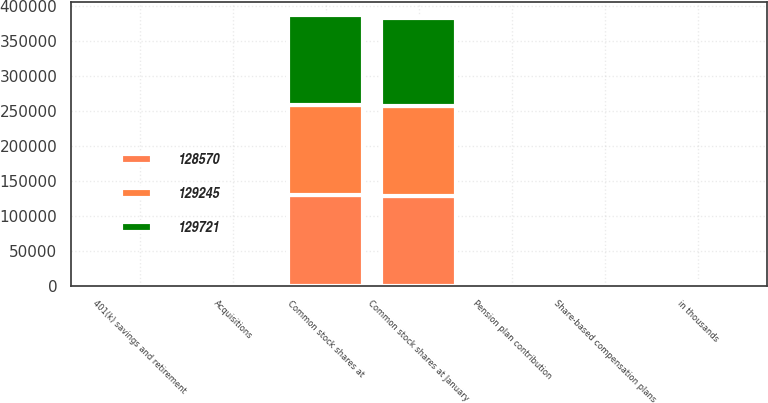Convert chart. <chart><loc_0><loc_0><loc_500><loc_500><stacked_bar_chart><ecel><fcel>in thousands<fcel>Common stock shares at January<fcel>Acquisitions<fcel>401(k) savings and retirement<fcel>Pension plan contribution<fcel>Share-based compensation plans<fcel>Common stock shares at<nl><fcel>129245<fcel>2012<fcel>129245<fcel>61<fcel>0<fcel>0<fcel>415<fcel>129721<nl><fcel>128570<fcel>2011<fcel>128570<fcel>373<fcel>111<fcel>0<fcel>191<fcel>129245<nl><fcel>129721<fcel>2010<fcel>125912<fcel>0<fcel>882<fcel>1190<fcel>586<fcel>128570<nl></chart> 